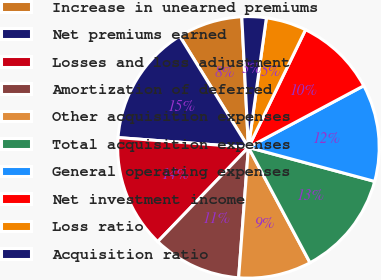Convert chart. <chart><loc_0><loc_0><loc_500><loc_500><pie_chart><fcel>Increase in unearned premiums<fcel>Net premiums earned<fcel>Losses and loss adjustment<fcel>Amortization of deferred<fcel>Other acquisition expenses<fcel>Total acquisition expenses<fcel>General operating expenses<fcel>Net investment income<fcel>Loss ratio<fcel>Acquisition ratio<nl><fcel>8.0%<fcel>15.0%<fcel>14.0%<fcel>11.0%<fcel>9.0%<fcel>13.0%<fcel>12.0%<fcel>10.0%<fcel>5.0%<fcel>3.0%<nl></chart> 